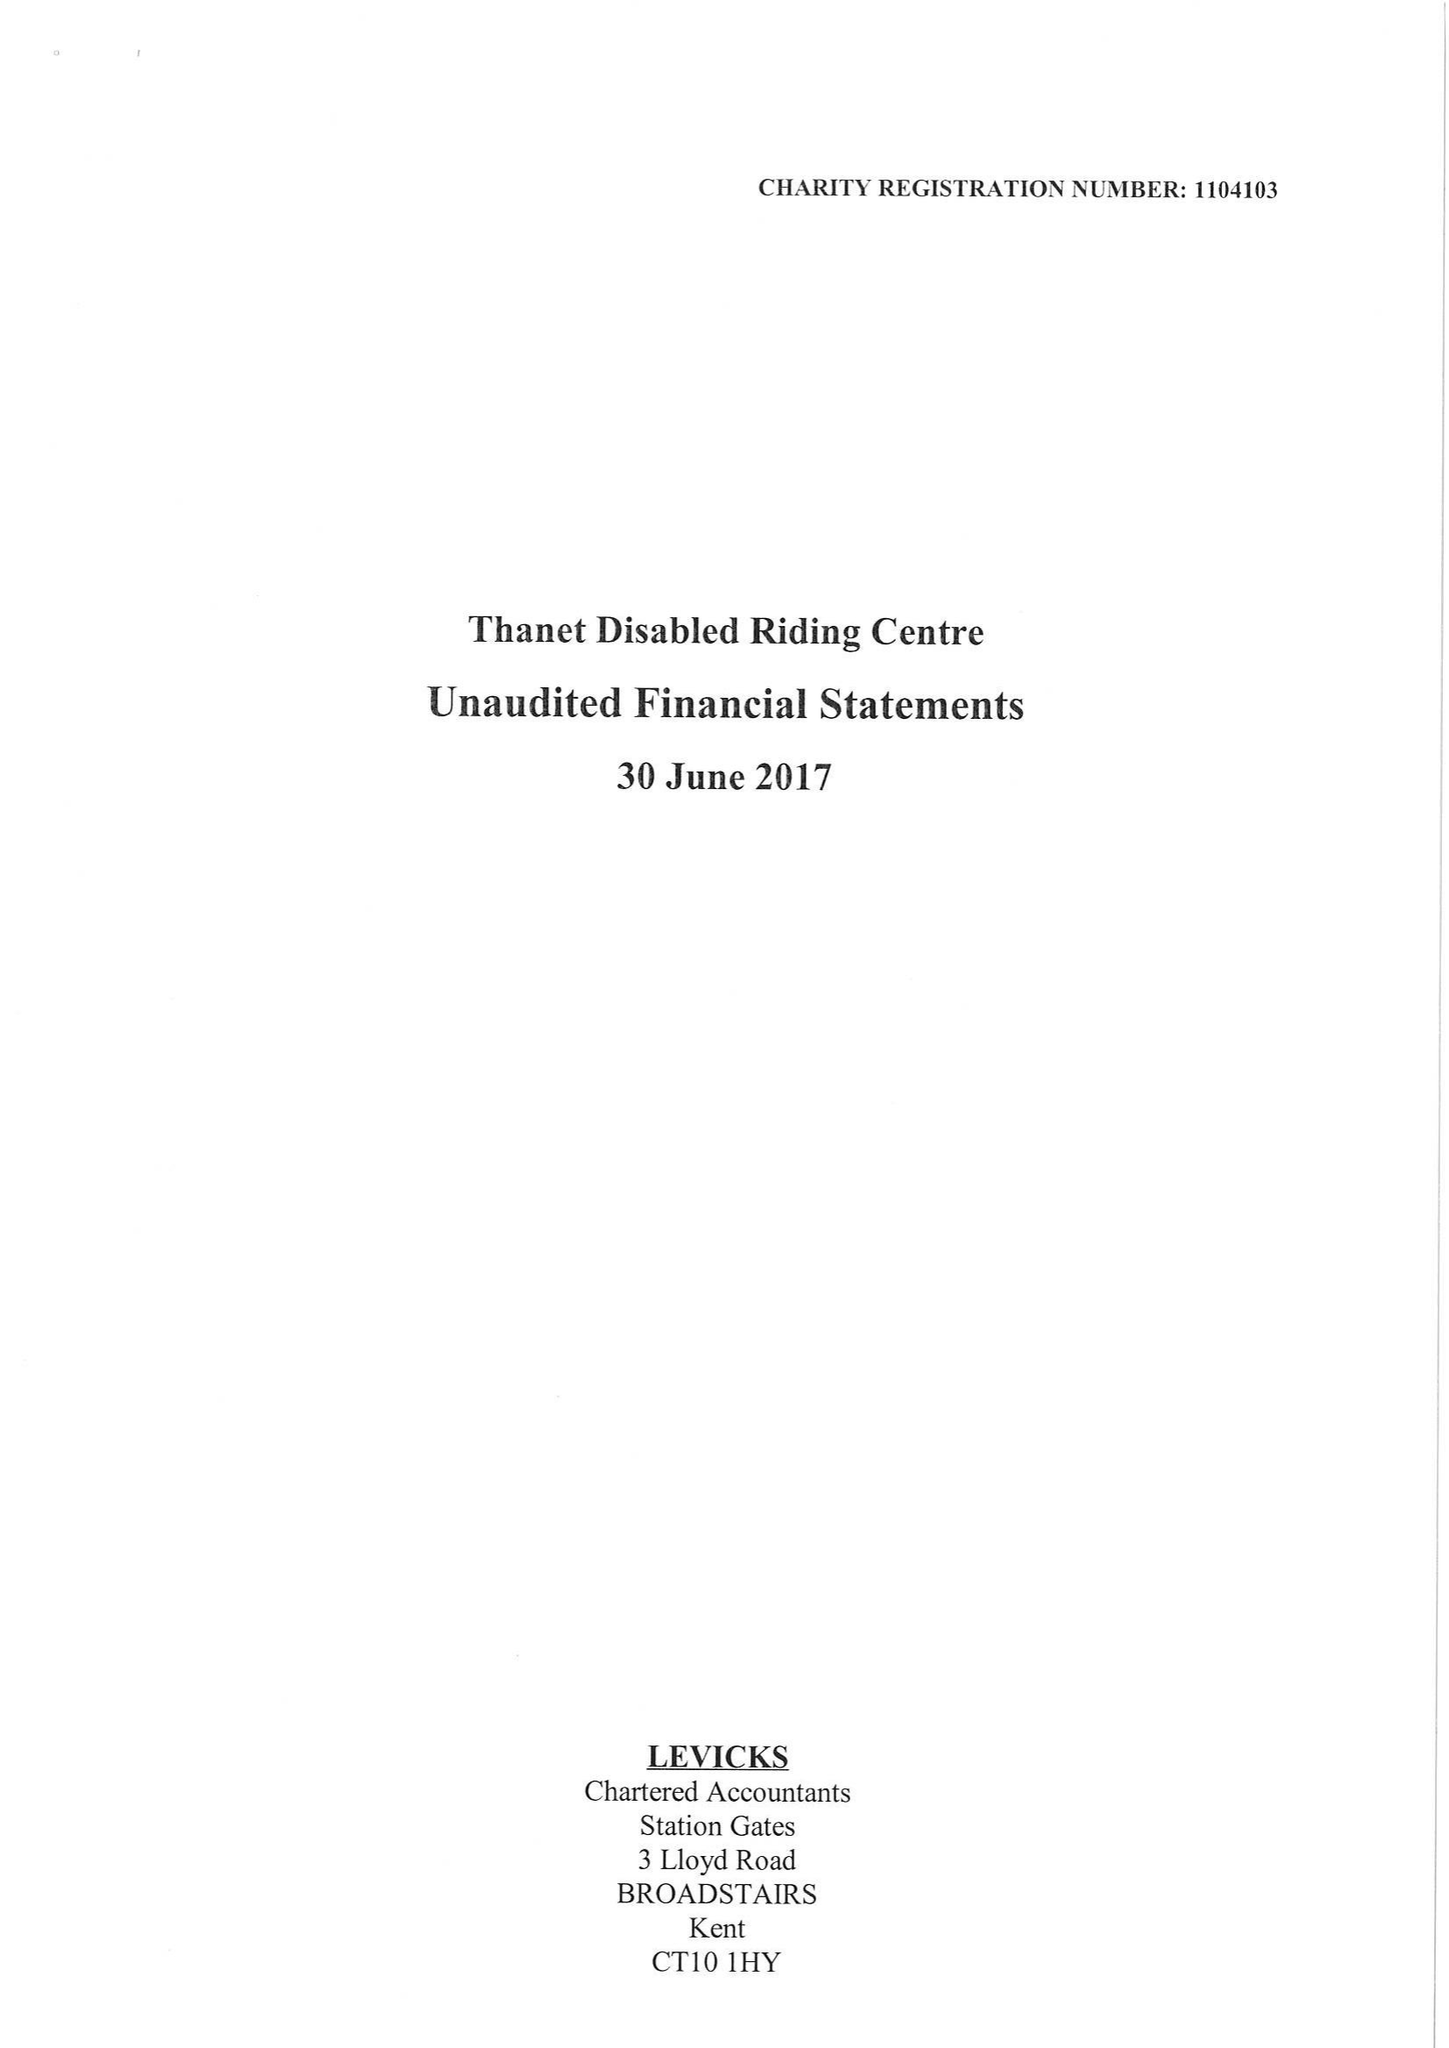What is the value for the income_annually_in_british_pounds?
Answer the question using a single word or phrase. 42540.00 